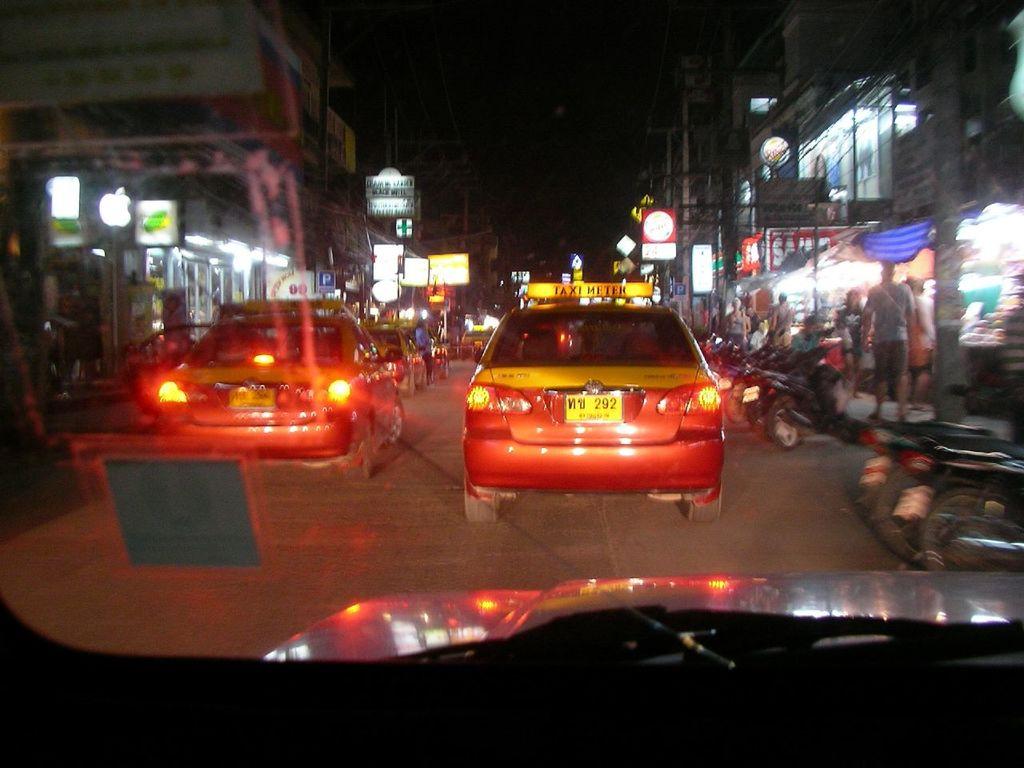What kind of car is the yellow?
Provide a succinct answer. Taxi. This is cars and bike?
Provide a short and direct response. Answering does not require reading text in the image. 